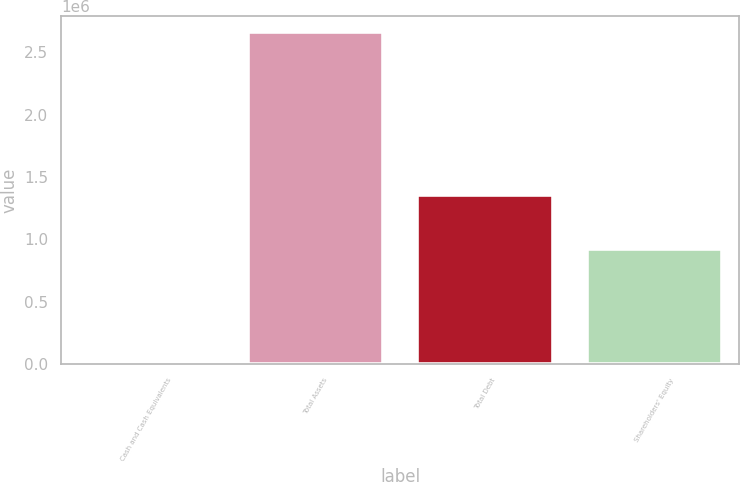Convert chart to OTSL. <chart><loc_0><loc_0><loc_500><loc_500><bar_chart><fcel>Cash and Cash Equivalents<fcel>Total Assets<fcel>Total Debt<fcel>Shareholders' Equity<nl><fcel>6200<fcel>2.6591e+06<fcel>1.35513e+06<fcel>924458<nl></chart> 